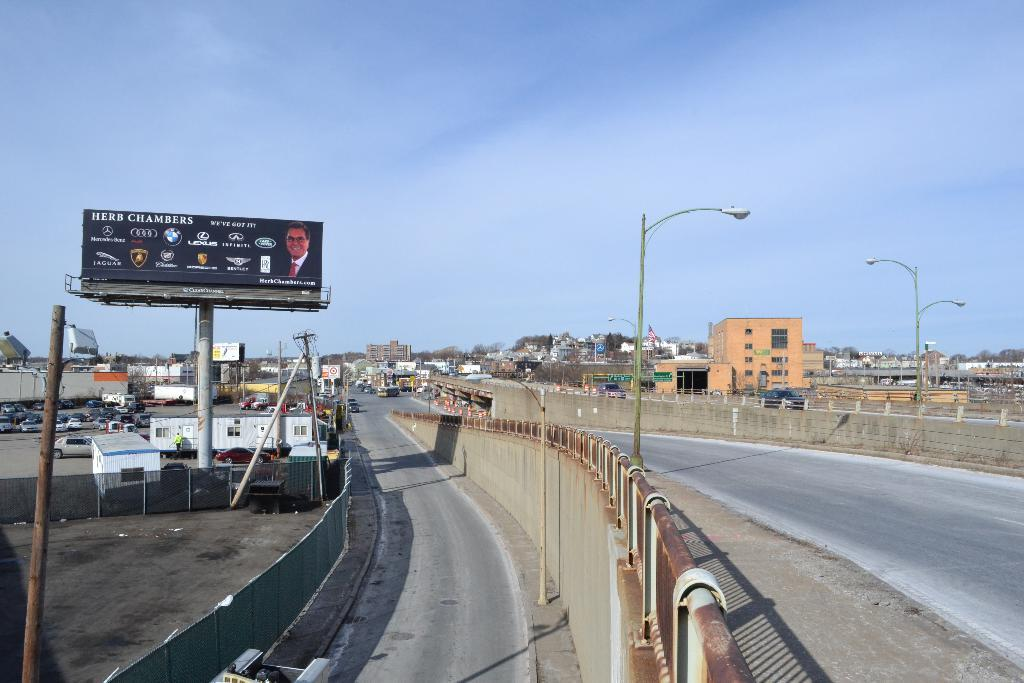Provide a one-sentence caption for the provided image. A highway scene including a billboard for Herb Chambers' auto dealership. 